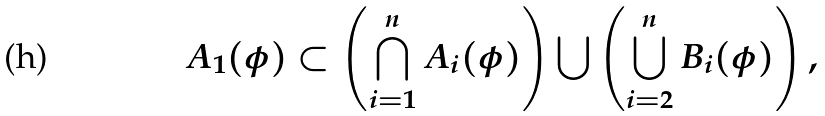Convert formula to latex. <formula><loc_0><loc_0><loc_500><loc_500>A _ { 1 } ( \phi ) \subset \left ( \bigcap _ { i = 1 } ^ { n } A _ { i } ( \phi ) \right ) \bigcup \left ( \bigcup _ { i = 2 } ^ { n } B _ { i } ( \phi ) \right ) ,</formula> 